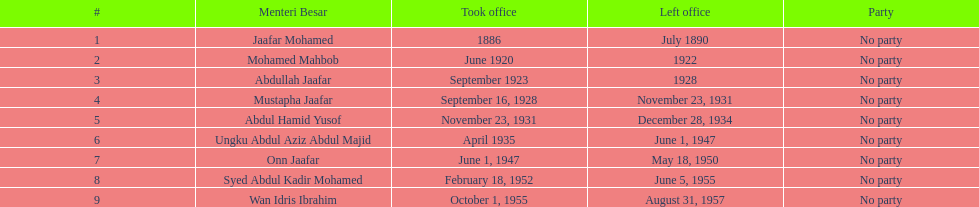What is the quantity of menteri besar who served for 4 or more years? 3. 